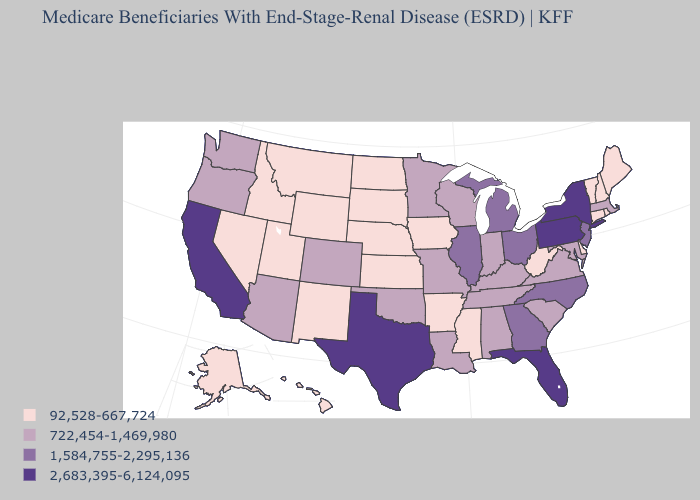Does Maine have the highest value in the USA?
Keep it brief. No. What is the highest value in states that border Louisiana?
Concise answer only. 2,683,395-6,124,095. Name the states that have a value in the range 92,528-667,724?
Answer briefly. Alaska, Arkansas, Connecticut, Delaware, Hawaii, Idaho, Iowa, Kansas, Maine, Mississippi, Montana, Nebraska, Nevada, New Hampshire, New Mexico, North Dakota, Rhode Island, South Dakota, Utah, Vermont, West Virginia, Wyoming. What is the value of North Carolina?
Give a very brief answer. 1,584,755-2,295,136. What is the value of Ohio?
Quick response, please. 1,584,755-2,295,136. What is the value of Connecticut?
Short answer required. 92,528-667,724. Which states have the highest value in the USA?
Be succinct. California, Florida, New York, Pennsylvania, Texas. Among the states that border Nevada , which have the lowest value?
Keep it brief. Idaho, Utah. Among the states that border Minnesota , which have the lowest value?
Write a very short answer. Iowa, North Dakota, South Dakota. Does the first symbol in the legend represent the smallest category?
Short answer required. Yes. What is the lowest value in the USA?
Give a very brief answer. 92,528-667,724. Does Oklahoma have a higher value than Alaska?
Write a very short answer. Yes. What is the value of Nevada?
Keep it brief. 92,528-667,724. Does New Hampshire have the lowest value in the Northeast?
Keep it brief. Yes. Is the legend a continuous bar?
Be succinct. No. 